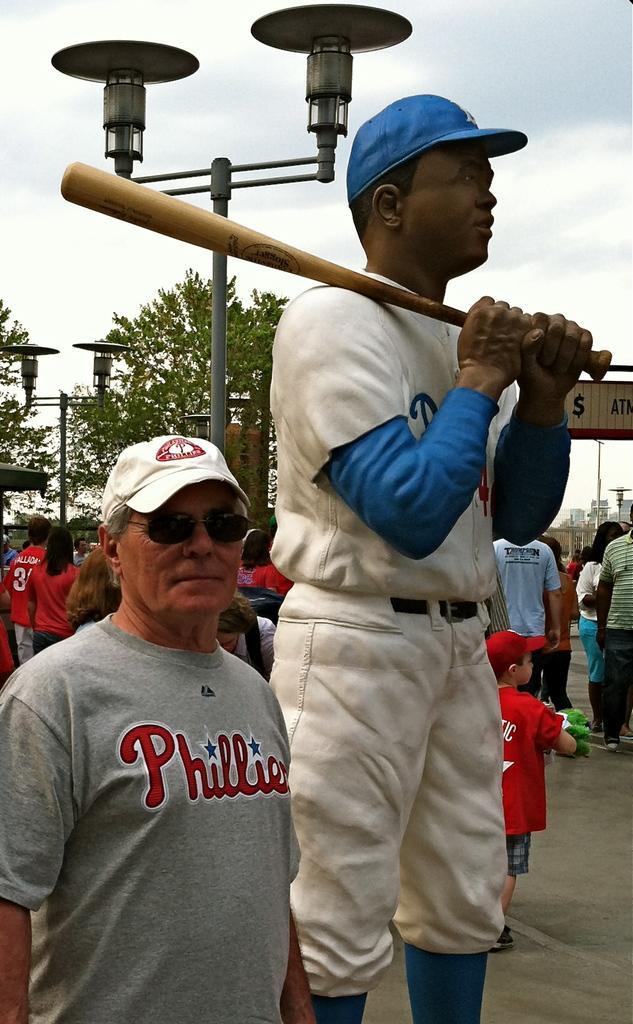Could you give a brief overview of what you see in this image? In the center of the image there is a depiction of a person holding a baseball bat. Beside him there is a person wearing a white color cap. In the background of the image there are people, trees, poles, sky. At the bottom of the image there is road. 